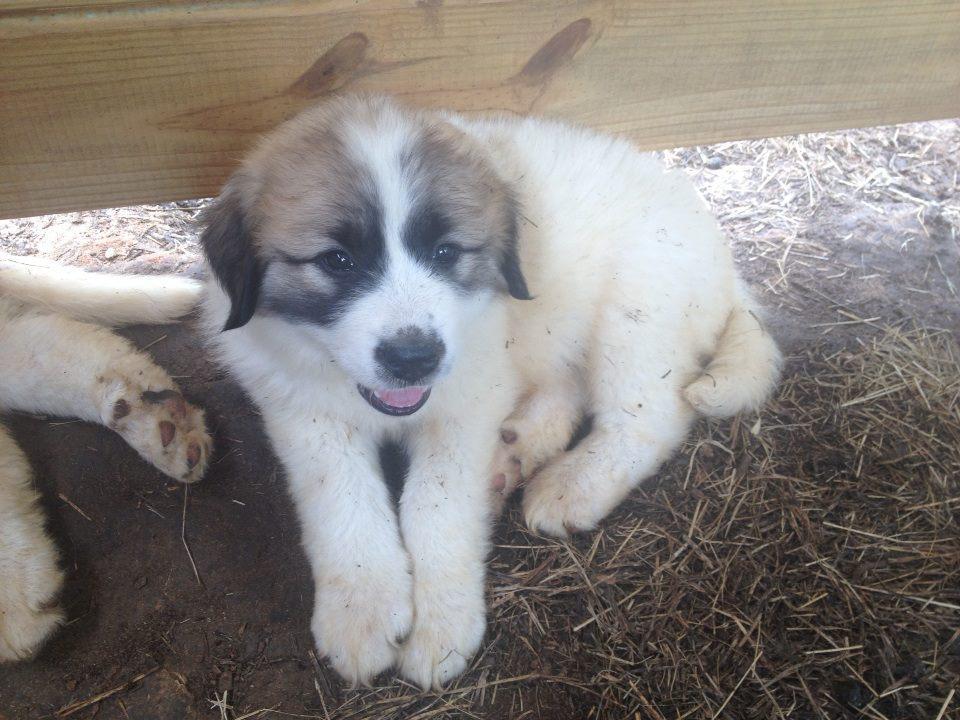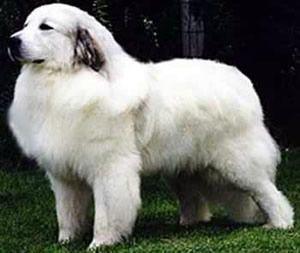The first image is the image on the left, the second image is the image on the right. For the images displayed, is the sentence "One of the images features an adult dog on green grass." factually correct? Answer yes or no. Yes. The first image is the image on the left, the second image is the image on the right. Analyze the images presented: Is the assertion "Each image shows one young puppy, and at least one image shows a brown-eared puppy reclining with its front paws forward." valid? Answer yes or no. No. 